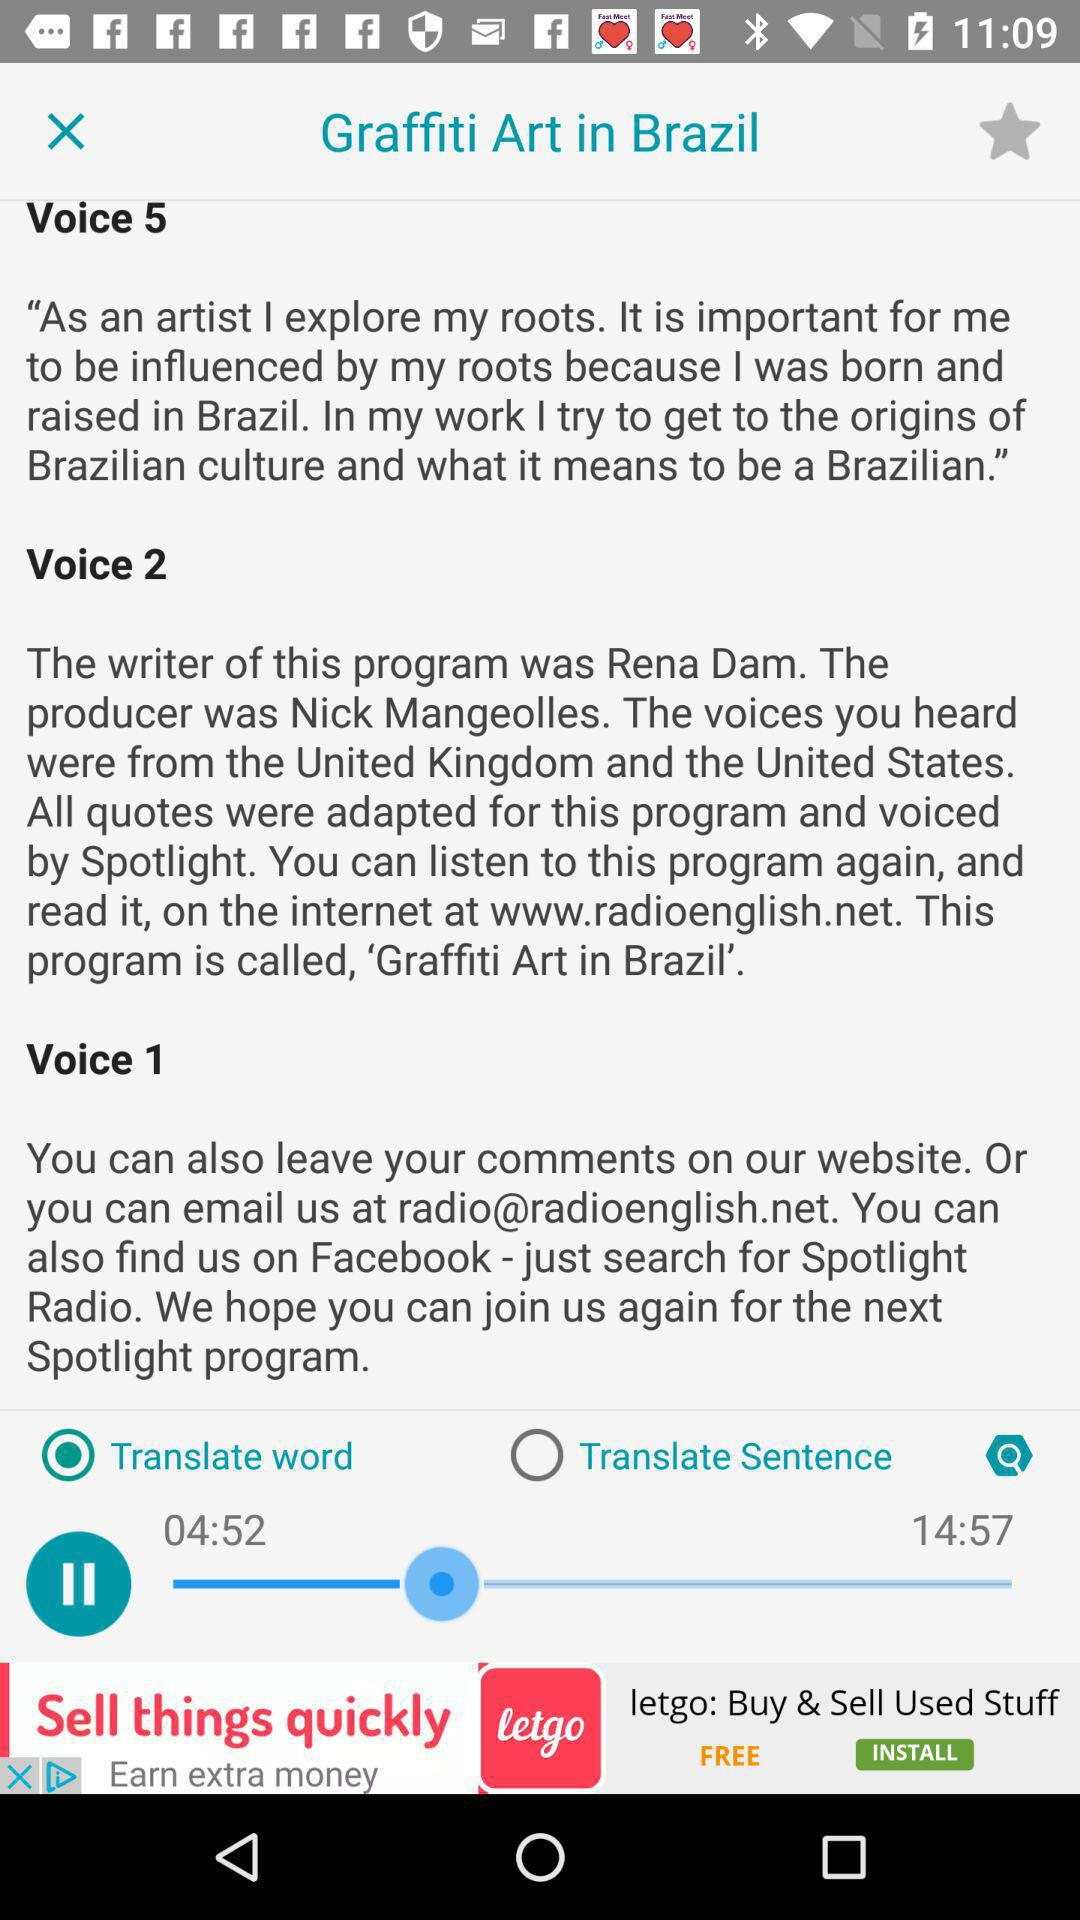What option is selected to translate? The selected option is translated word. 